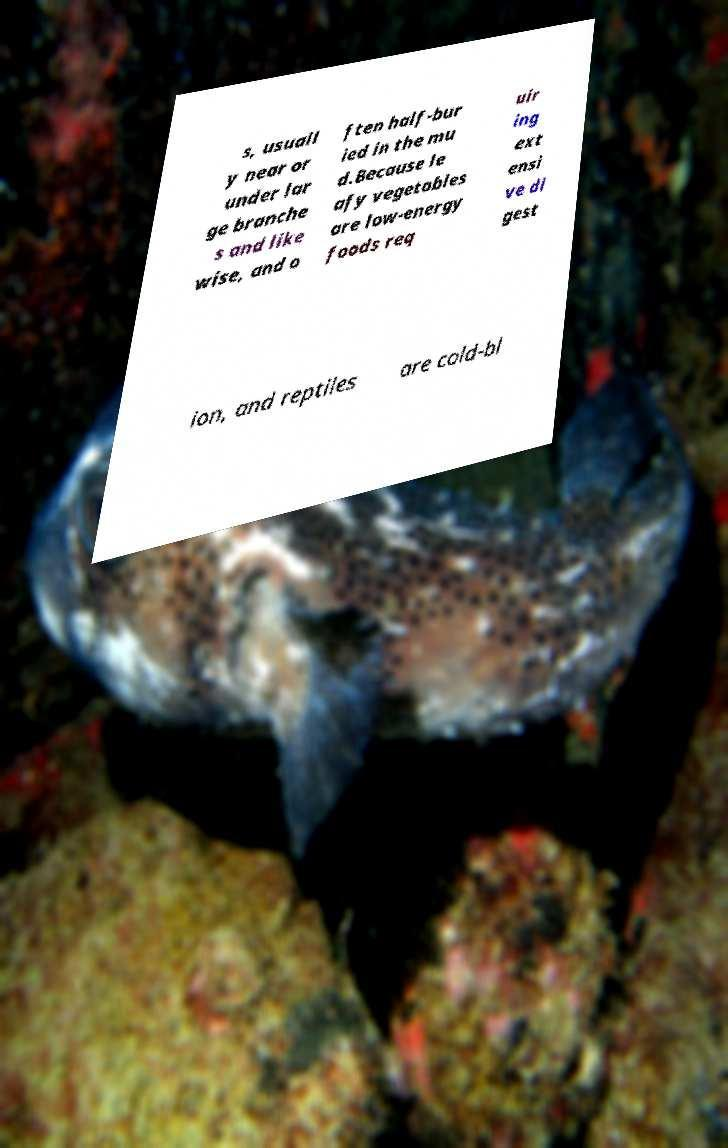Please identify and transcribe the text found in this image. s, usuall y near or under lar ge branche s and like wise, and o ften half-bur ied in the mu d.Because le afy vegetables are low-energy foods req uir ing ext ensi ve di gest ion, and reptiles are cold-bl 